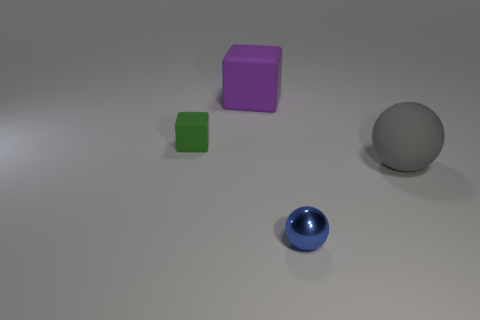What material is the object that is behind the matte sphere and in front of the purple rubber thing?
Your answer should be very brief. Rubber. The gray rubber ball has what size?
Give a very brief answer. Large. How many other things are the same color as the tiny block?
Give a very brief answer. 0. Is the size of the ball in front of the gray ball the same as the matte block in front of the big purple block?
Make the answer very short. Yes. What color is the small object on the left side of the large purple cube?
Ensure brevity in your answer.  Green. Are there fewer green rubber objects on the right side of the blue metal object than green rubber objects?
Offer a very short reply. Yes. Is the material of the large sphere the same as the blue thing?
Keep it short and to the point. No. What is the size of the other matte object that is the same shape as the small green object?
Ensure brevity in your answer.  Large. What number of things are either small things that are to the left of the purple cube or big things that are in front of the green rubber block?
Your answer should be very brief. 2. Are there fewer blue shiny cylinders than large matte cubes?
Offer a terse response. Yes. 